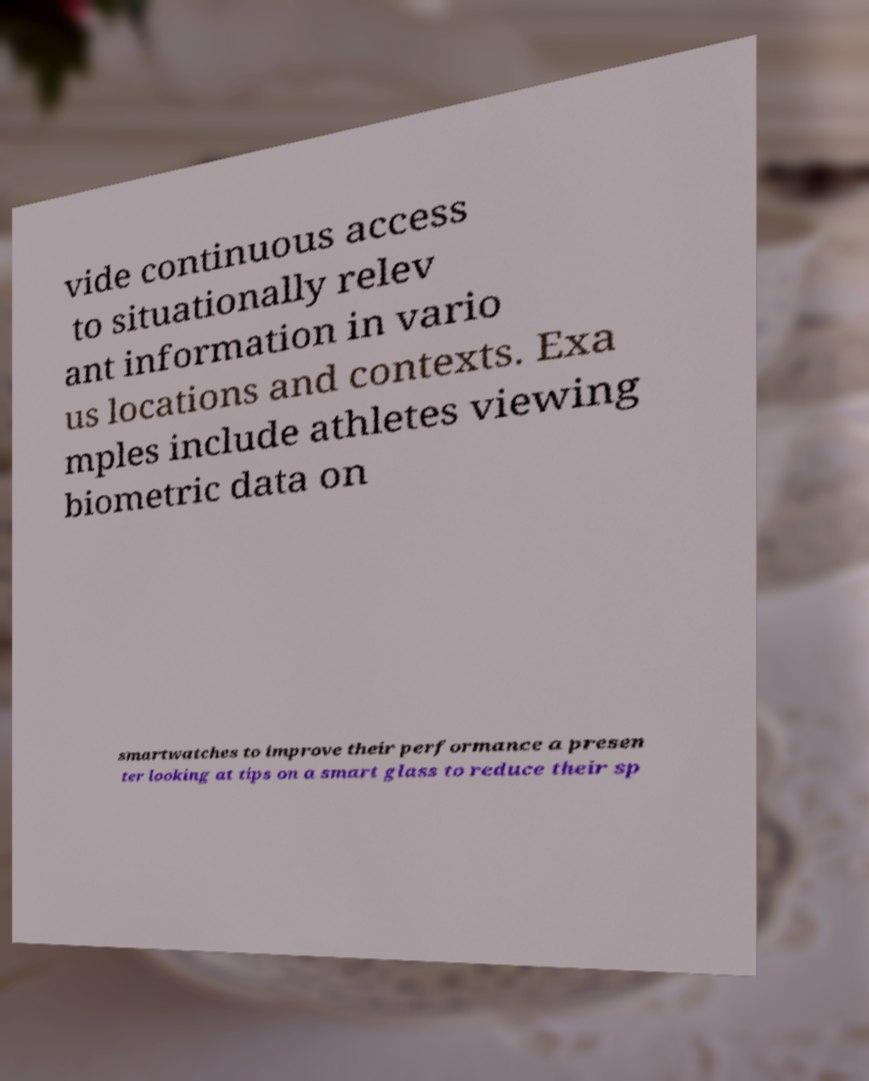Could you assist in decoding the text presented in this image and type it out clearly? vide continuous access to situationally relev ant information in vario us locations and contexts. Exa mples include athletes viewing biometric data on smartwatches to improve their performance a presen ter looking at tips on a smart glass to reduce their sp 